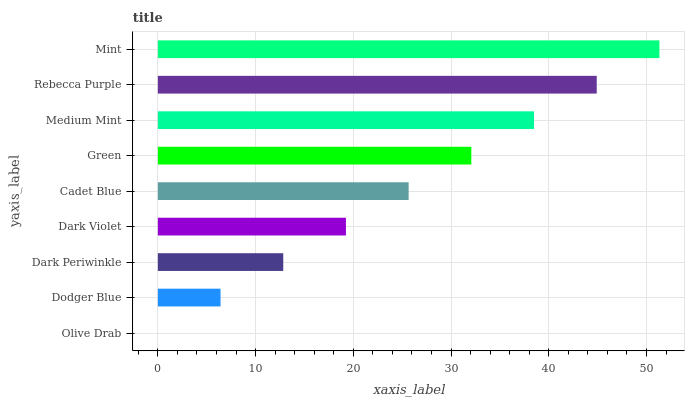Is Olive Drab the minimum?
Answer yes or no. Yes. Is Mint the maximum?
Answer yes or no. Yes. Is Dodger Blue the minimum?
Answer yes or no. No. Is Dodger Blue the maximum?
Answer yes or no. No. Is Dodger Blue greater than Olive Drab?
Answer yes or no. Yes. Is Olive Drab less than Dodger Blue?
Answer yes or no. Yes. Is Olive Drab greater than Dodger Blue?
Answer yes or no. No. Is Dodger Blue less than Olive Drab?
Answer yes or no. No. Is Cadet Blue the high median?
Answer yes or no. Yes. Is Cadet Blue the low median?
Answer yes or no. Yes. Is Dark Periwinkle the high median?
Answer yes or no. No. Is Dark Periwinkle the low median?
Answer yes or no. No. 